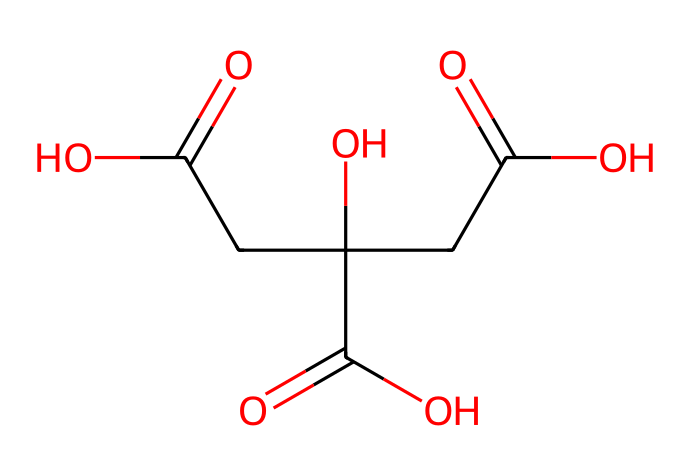How many carbon atoms are present in citric acid? By examining the SMILES representation, we can count the carbon (C) atoms in the formula. Looking closely at the structure given—and knowing it corresponds to citric acid—we find there are six carbon atoms in total.
Answer: six What functional groups are found in citric acid? The SMILES representation indicates several functional groups within the structure. We can identify that citric acid contains carboxylic acid groups, as observed from the presence of the -COOH parts in the structure.
Answer: carboxylic acid What is the molecular formula of citric acid? Based on the SMILES representation, we can deduce the molecular formula by counting the numbers of each type of atom. In total, there are six carbon atoms, eight hydrogen atoms, and seven oxygen atoms, leading us to the molecular formula C6H8O7.
Answer: C6H8O7 How many hydroxyl groups are present in citric acid? In the SMILES structure, we can identify the -OH parts (hydroxyl groups). There are two such groups in the structure of citric acid, as indicated by the -OH connections.
Answer: two What type of acid is citric acid classified as? Citric acid, as per its structure observed in the SMILES notation, is classified as a weak organic acid due to the presence of multiple carboxylic acid groups that can partially dissociate in solution.
Answer: weak organic acid What effect does citric acid have on pH in baking? Citric acid, being an acidic compound, lowers the pH when added to baking recipes. This reduction in pH can influence the overall flavor and chemical reactions during baking processes.
Answer: lowers pH Which part of the chemical structure primarily defines its acidic nature? The presence of the carboxylic acid functional groups (-COOH) in the SMILES structure is what primarily defines citric acid's acidic nature and its ability to donate protons (H+).
Answer: carboxylic acid groups 